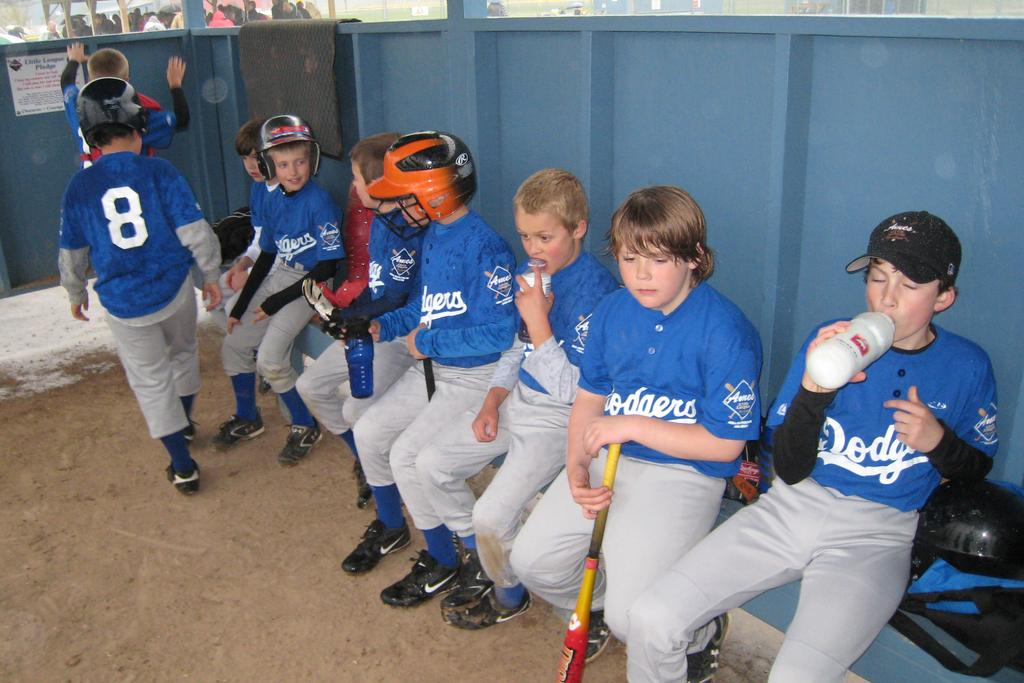<image>
Summarize the visual content of the image. All the kids in the dugout play for the Dodgers. 